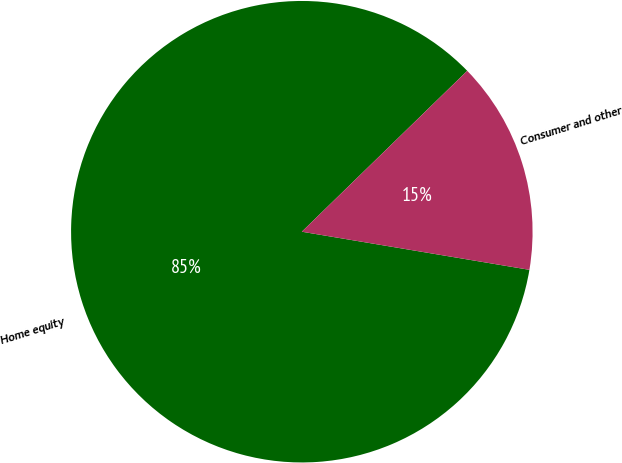Convert chart. <chart><loc_0><loc_0><loc_500><loc_500><pie_chart><fcel>Home equity<fcel>Consumer and other<nl><fcel>85.08%<fcel>14.92%<nl></chart> 